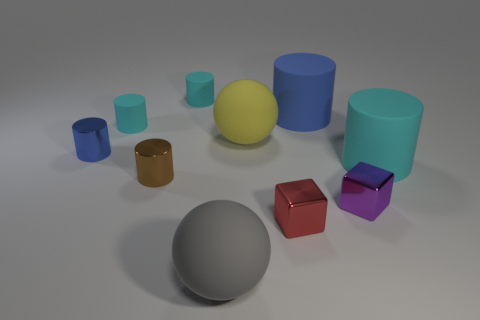Do the blue matte object and the yellow ball have the same size? yes 